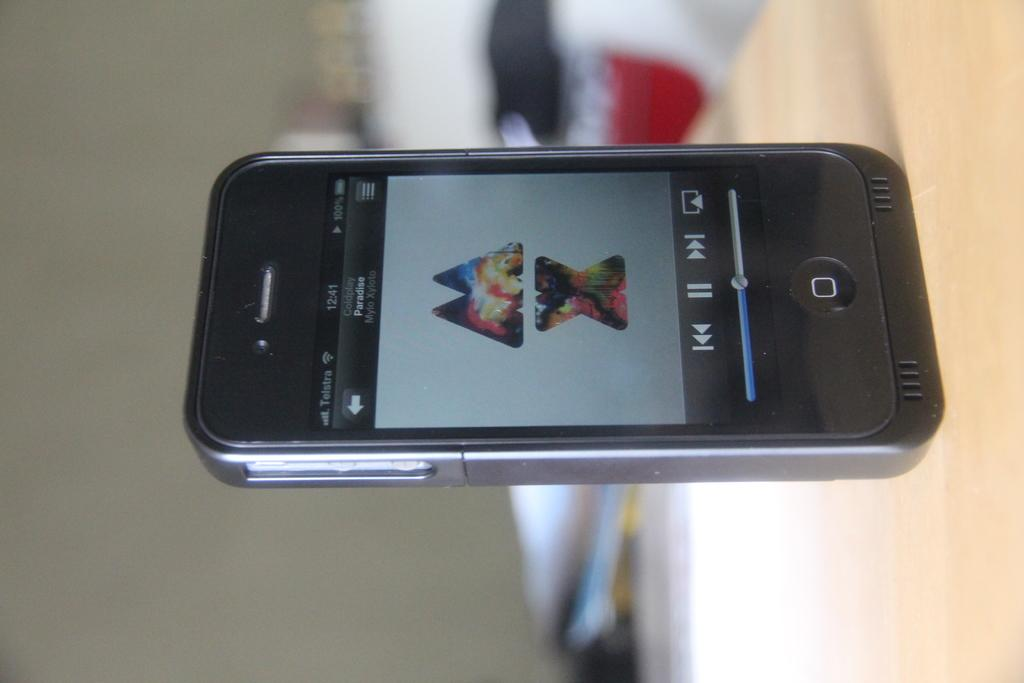<image>
Present a compact description of the photo's key features. The letters M and X appear stacked on a cellphone screen. 